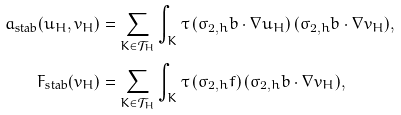Convert formula to latex. <formula><loc_0><loc_0><loc_500><loc_500>a _ { \text {stab} } ( u _ { H } , v _ { H } ) & = \sum _ { K \in \mathcal { T } _ { H } } \int _ { K } \tau \, ( \sigma _ { 2 , h } b \cdot \nabla u _ { H } ) \, ( \sigma _ { 2 , h } b \cdot \nabla v _ { H } ) , \\ F _ { \text {stab} } ( v _ { H } ) & = \sum _ { K \in \mathcal { T } _ { H } } \int _ { K } \tau \, ( \sigma _ { 2 , h } f ) \, ( \sigma _ { 2 , h } b \cdot \nabla v _ { H } ) ,</formula> 